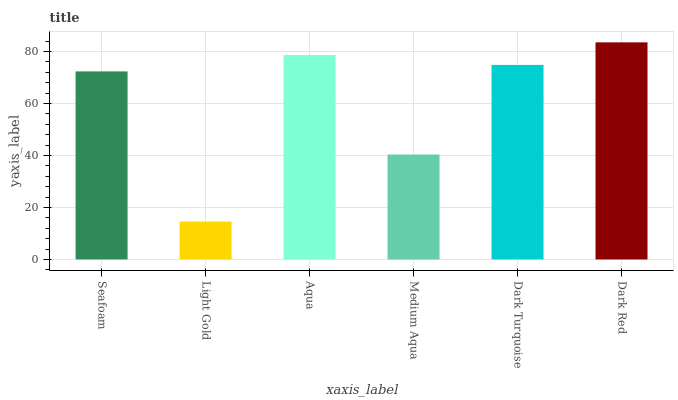Is Light Gold the minimum?
Answer yes or no. Yes. Is Dark Red the maximum?
Answer yes or no. Yes. Is Aqua the minimum?
Answer yes or no. No. Is Aqua the maximum?
Answer yes or no. No. Is Aqua greater than Light Gold?
Answer yes or no. Yes. Is Light Gold less than Aqua?
Answer yes or no. Yes. Is Light Gold greater than Aqua?
Answer yes or no. No. Is Aqua less than Light Gold?
Answer yes or no. No. Is Dark Turquoise the high median?
Answer yes or no. Yes. Is Seafoam the low median?
Answer yes or no. Yes. Is Seafoam the high median?
Answer yes or no. No. Is Dark Red the low median?
Answer yes or no. No. 